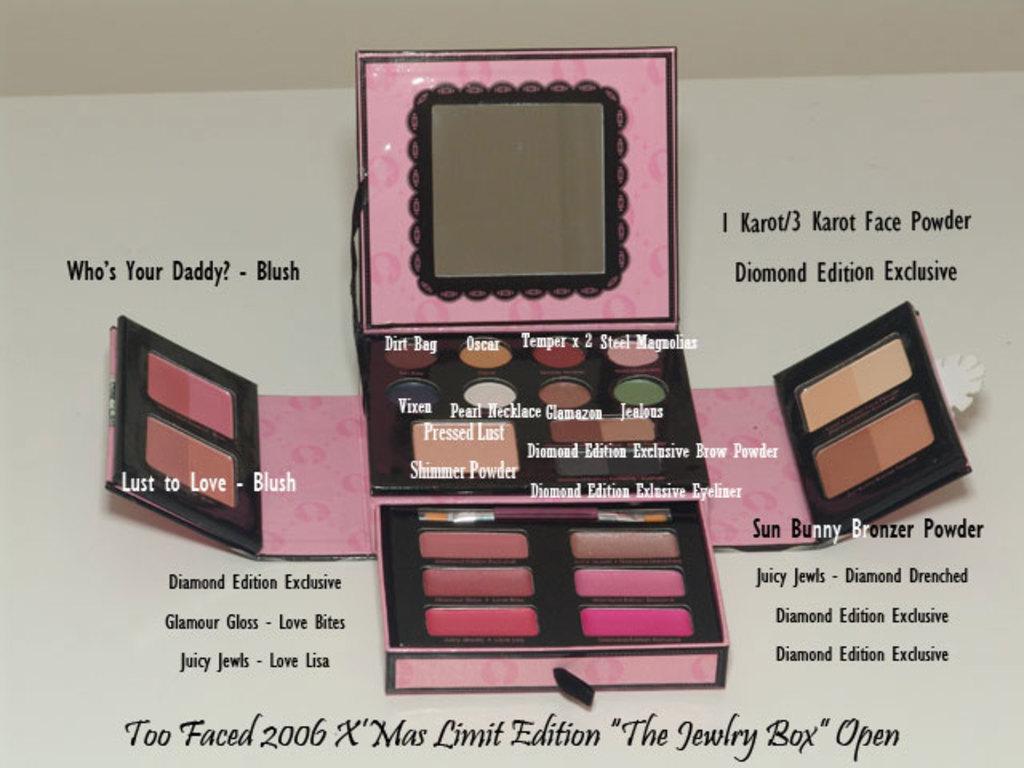Is the too faced makeup box for sale?
Make the answer very short. Yes. Who is your daddy?
Keep it short and to the point. Blush. 